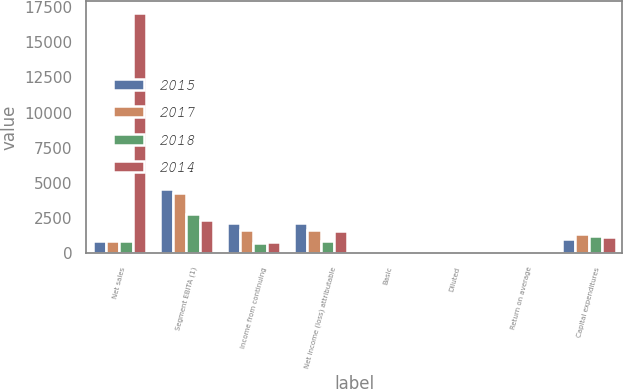<chart> <loc_0><loc_0><loc_500><loc_500><stacked_bar_chart><ecel><fcel>Net sales<fcel>Segment EBITA (1)<fcel>Income from continuing<fcel>Net income (loss) attributable<fcel>Basic<fcel>Diluted<fcel>Return on average<fcel>Capital expenditures<nl><fcel>2015<fcel>868<fcel>4555<fcel>2162<fcel>2162<fcel>2.34<fcel>2.32<fcel>10<fcel>1030<nl><fcel>2017<fcel>868<fcel>4258<fcel>1654<fcel>1611<fcel>1.77<fcel>1.75<fcel>7<fcel>1343<nl><fcel>2018<fcel>868<fcel>2754<fcel>732<fcel>868<fcel>1.1<fcel>1.09<fcel>4<fcel>1249<nl><fcel>2014<fcel>17100<fcel>2327<fcel>814<fcel>1563<fcel>1.24<fcel>1.23<fcel>8<fcel>1135<nl></chart> 